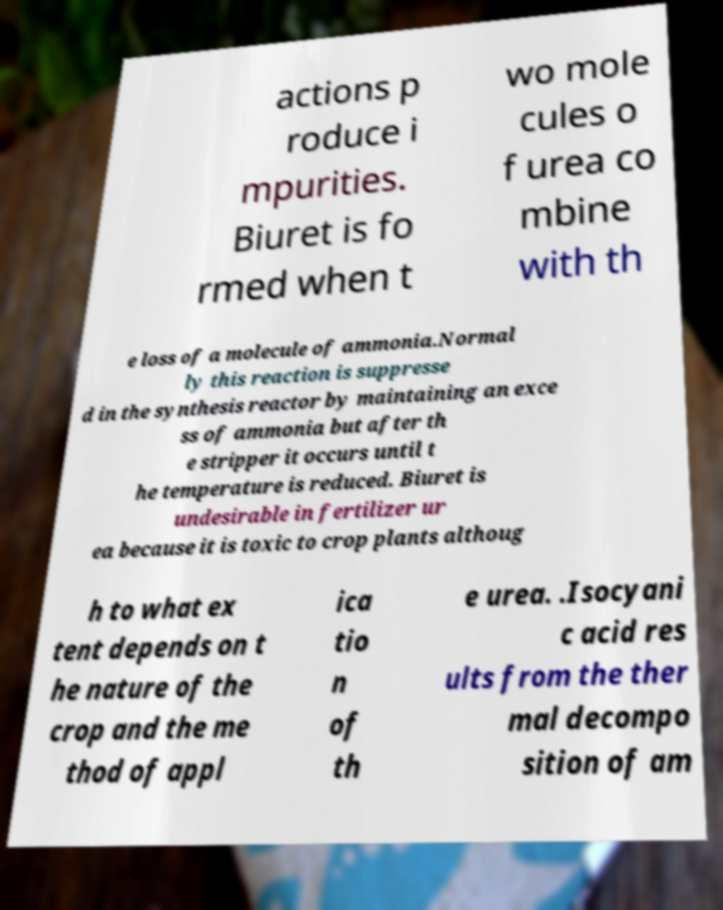What messages or text are displayed in this image? I need them in a readable, typed format. actions p roduce i mpurities. Biuret is fo rmed when t wo mole cules o f urea co mbine with th e loss of a molecule of ammonia.Normal ly this reaction is suppresse d in the synthesis reactor by maintaining an exce ss of ammonia but after th e stripper it occurs until t he temperature is reduced. Biuret is undesirable in fertilizer ur ea because it is toxic to crop plants althoug h to what ex tent depends on t he nature of the crop and the me thod of appl ica tio n of th e urea. .Isocyani c acid res ults from the ther mal decompo sition of am 